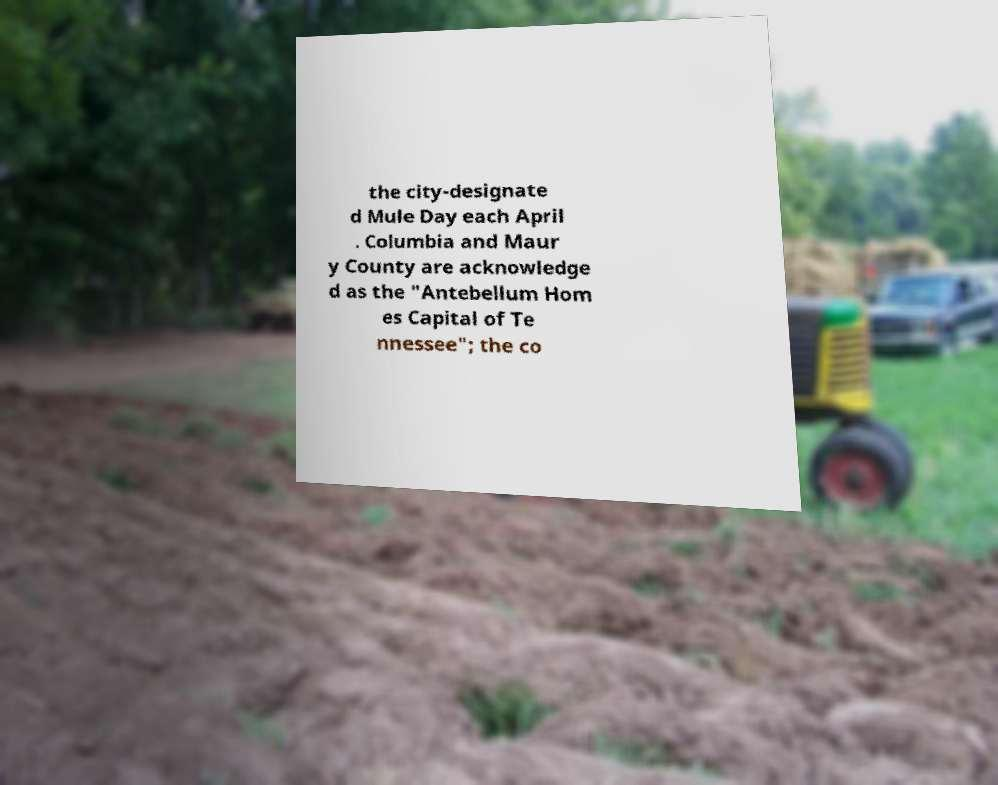There's text embedded in this image that I need extracted. Can you transcribe it verbatim? the city-designate d Mule Day each April . Columbia and Maur y County are acknowledge d as the "Antebellum Hom es Capital of Te nnessee"; the co 